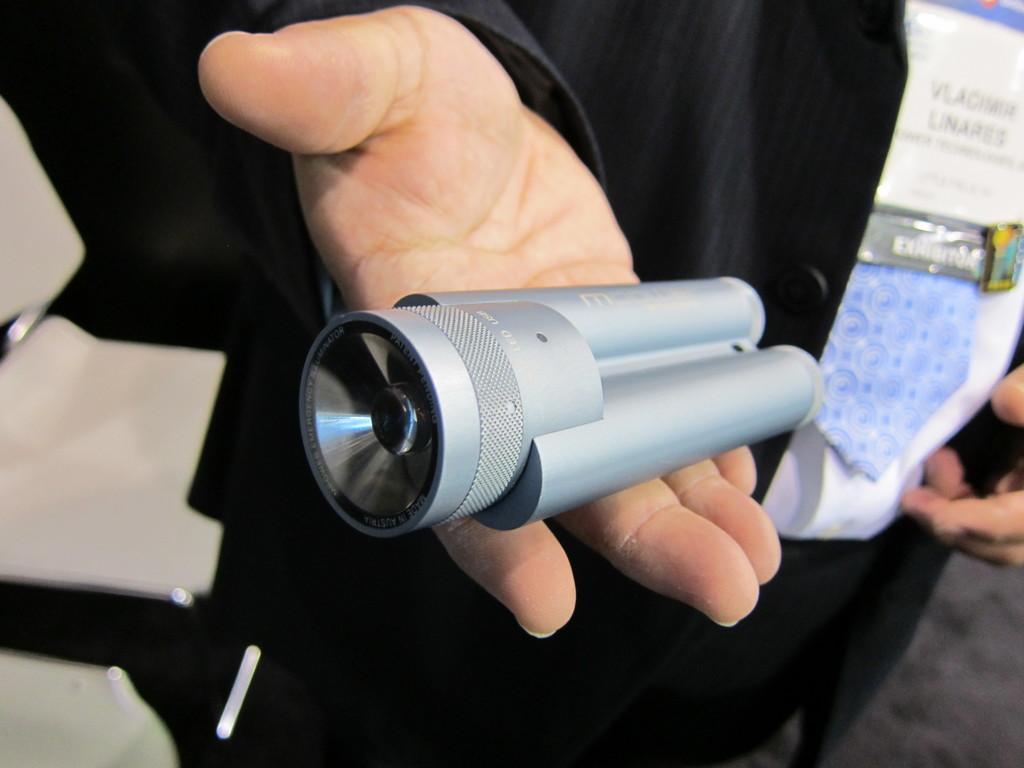Can you describe this image briefly? In this image we can see a person wearing black color suit holding some torch light in his hands which is of grey color. 